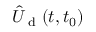<formula> <loc_0><loc_0><loc_500><loc_500>\hat { U } _ { d } ( t , t _ { 0 } )</formula> 